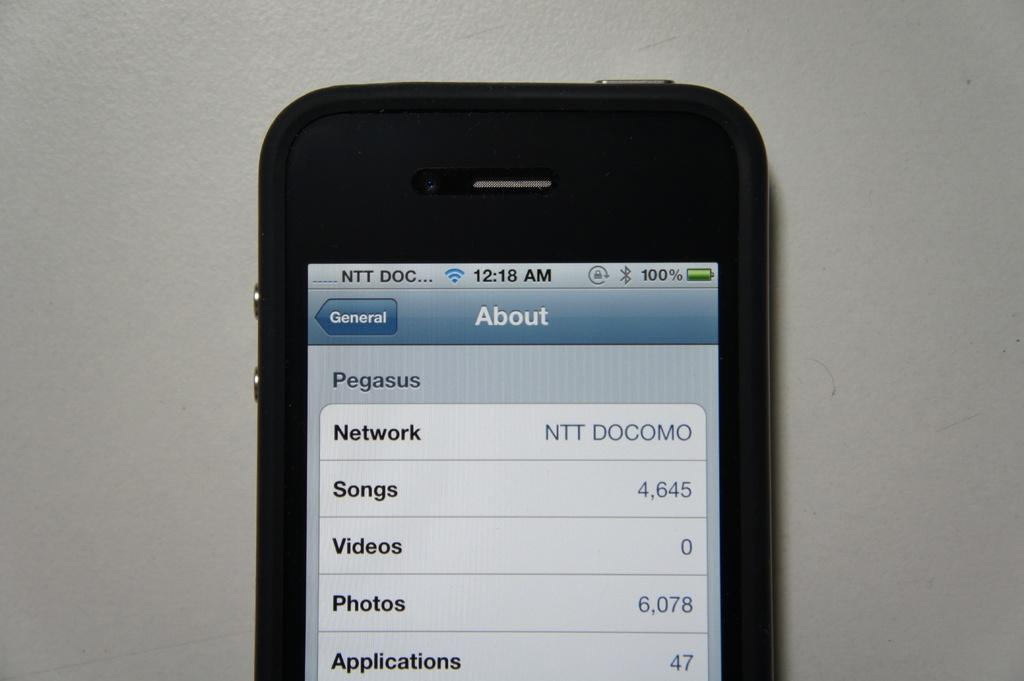<image>
Share a concise interpretation of the image provided. A phone screen is displaying the About page. 